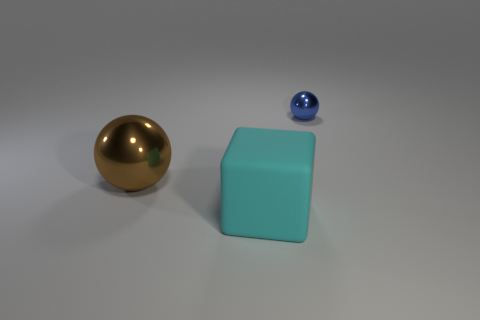Add 1 small balls. How many objects exist? 4 Subtract all blocks. How many objects are left? 2 Add 1 big rubber blocks. How many big rubber blocks are left? 2 Add 1 cyan blocks. How many cyan blocks exist? 2 Subtract 0 brown cylinders. How many objects are left? 3 Subtract all large metallic objects. Subtract all large green metal cubes. How many objects are left? 2 